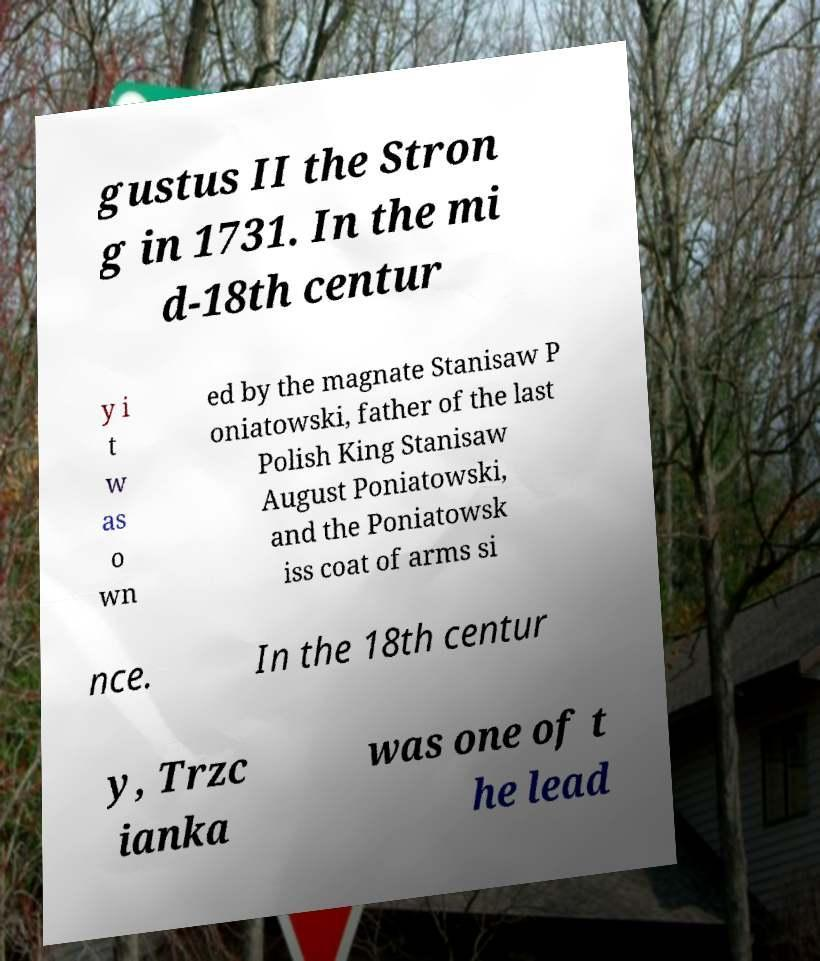Can you read and provide the text displayed in the image?This photo seems to have some interesting text. Can you extract and type it out for me? gustus II the Stron g in 1731. In the mi d-18th centur y i t w as o wn ed by the magnate Stanisaw P oniatowski, father of the last Polish King Stanisaw August Poniatowski, and the Poniatowsk iss coat of arms si nce. In the 18th centur y, Trzc ianka was one of t he lead 